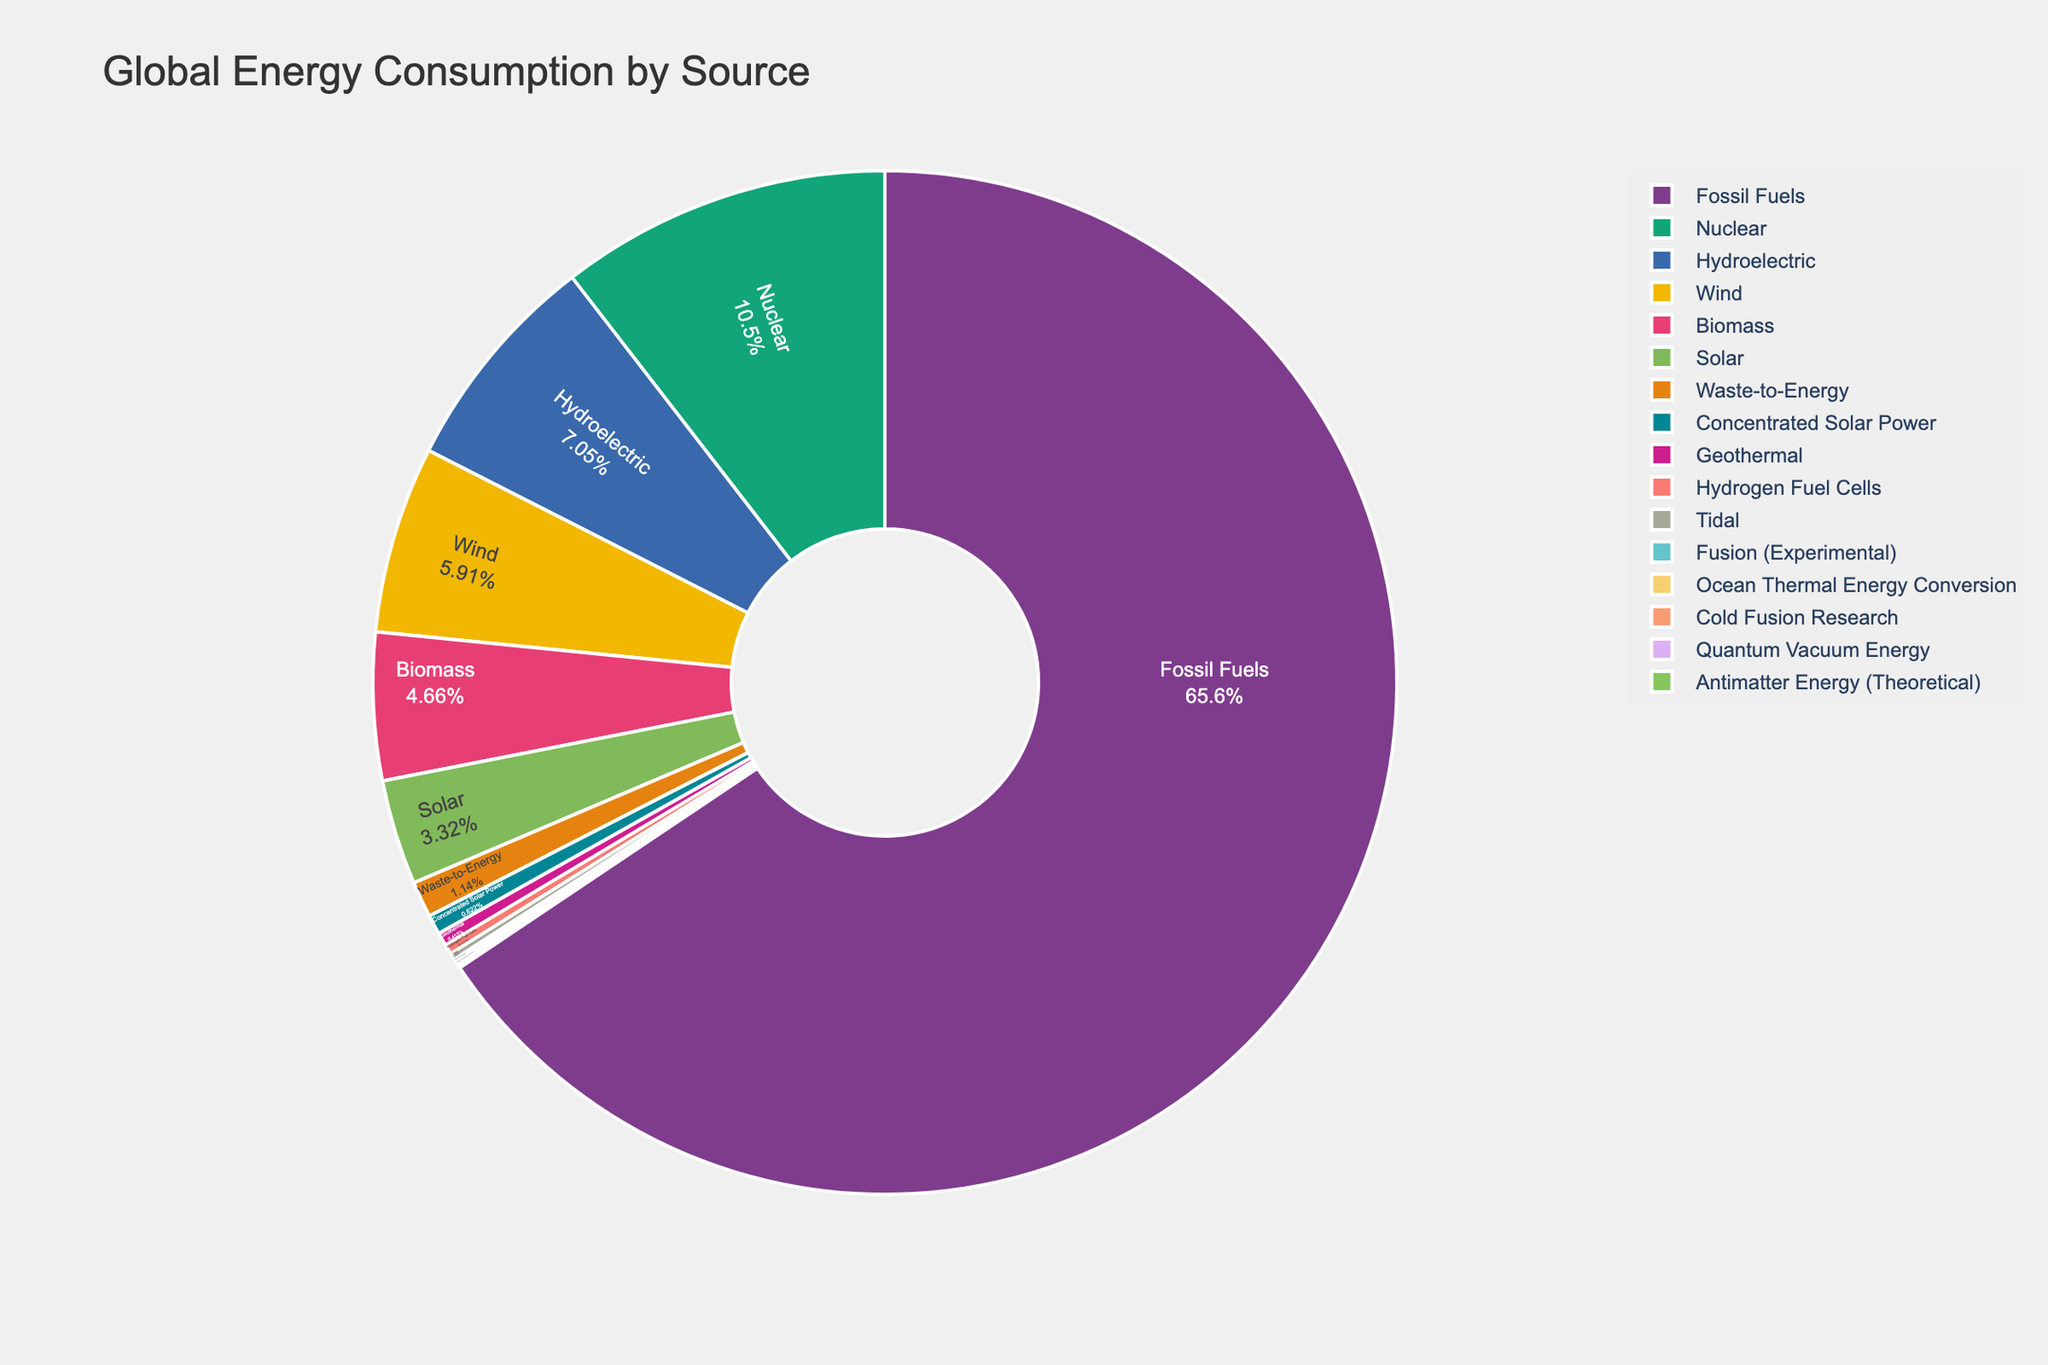What percentage of global energy consumption is from nuclear energy? To find the percentage of global energy consumption from nuclear energy, look for the segment labeled "Nuclear" on the pie chart. The percentage is displayed within this segment.
Answer: 10.1% Which energy source alone has the highest consumption percentage? To find the energy source with the highest consumption percentage, look for the largest segment on the pie chart. The label with the highest percentage will indicate the energy source.
Answer: Fossil Fuels How does the consumption percentage of wind energy compare to solar energy? Determine the percentages for both "Wind" and "Solar" segments. Compare the two values directly to understand which one is higher or if they are equal.
Answer: Wind is higher (5.7% vs 3.2%) What is the total percentage of energy consumption from hydroelectric, wind, and biomass? Find the percentages for "Hydroelectric," "Wind," and "Biomass," then sum them up: 6.8% + 5.7% + 4.5%.
Answer: 17% Is the consumption from experimental and theoretical sources (e.g., Fusion, Antimatter, Quantum Vacuum Energy) greater than 1% of the total energy consumption? Sum the percentages from "Fusion (Experimental)," "Antimatter Energy (Theoretical)," and "Quantum Vacuum Energy": 0.1% + 0.01% + 0.04%. Compare this with 1%.
Answer: No (0.15%) Between waste-to-energy and hydrogen fuel cells, which one contributes more to the total energy consumption? Locate the segments for "Waste-to-Energy" and "Hydrogen Fuel Cells" and compare their percentages.
Answer: Waste-to-Energy (1.1%) is higher than Hydrogen Fuel Cells (0.3%) What is the combined percentage of all non-fossil fuel energy sources? Sum the percentages of all energy sources excluding "Fossil Fuels." This includes Nuclear, Hydroelectric, Wind, Solar, Biomass, Geothermal, Fusion (Experimental), Tidal, Hydrogen Fuel Cells, Waste-to-Energy, Concentrated Solar Power, Ocean Thermal Energy Conversion, Cold Fusion Research, Antimatter Energy (Theoretical), and Quantum Vacuum Energy.
Answer: 36.7% What is the difference in consumption percentage between tidal energy and geothermal energy? Find the percentages for "Tidal" and "Geothermal," then subtract the smaller percentage from the larger one to find the difference: 0.4% - 0.2%.
Answer: 0.2% Which color segments represent "Fossil Fuels" and "Nuclear" energy sources? Visually identify the segments for "Fossil Fuels" and "Nuclear" on the pie chart, noting the colors used for these segments.
Answer: Fossil Fuels (red), Nuclear (blue) Which alternative energy source has the lowest consumption, and what is its percentage? Look for the smallest segment representing an alternative energy source and read its label and percentage.
Answer: Antimatter Energy (Theoretical), 0.01% 